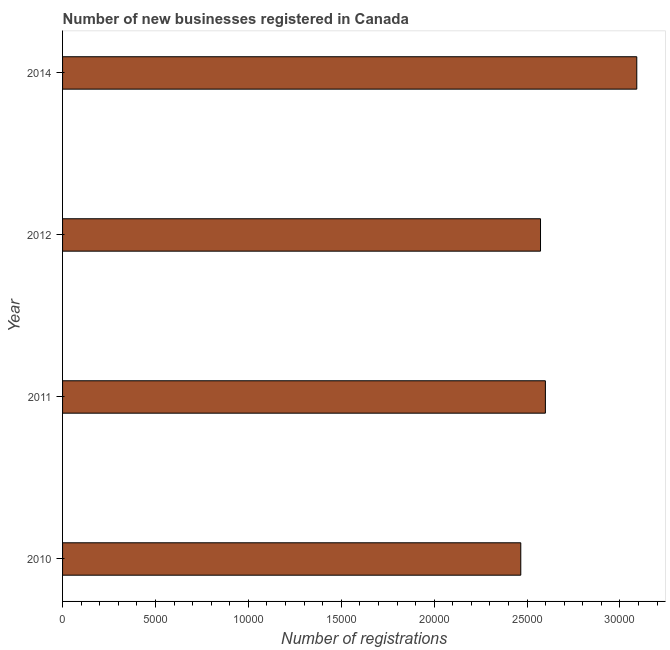Does the graph contain grids?
Keep it short and to the point. No. What is the title of the graph?
Provide a short and direct response. Number of new businesses registered in Canada. What is the label or title of the X-axis?
Give a very brief answer. Number of registrations. What is the label or title of the Y-axis?
Provide a short and direct response. Year. What is the number of new business registrations in 2014?
Ensure brevity in your answer.  3.09e+04. Across all years, what is the maximum number of new business registrations?
Keep it short and to the point. 3.09e+04. Across all years, what is the minimum number of new business registrations?
Your answer should be compact. 2.47e+04. In which year was the number of new business registrations minimum?
Offer a terse response. 2010. What is the sum of the number of new business registrations?
Provide a succinct answer. 1.07e+05. What is the difference between the number of new business registrations in 2010 and 2011?
Give a very brief answer. -1324. What is the average number of new business registrations per year?
Your response must be concise. 2.68e+04. What is the median number of new business registrations?
Provide a succinct answer. 2.59e+04. In how many years, is the number of new business registrations greater than 4000 ?
Your answer should be compact. 4. What is the ratio of the number of new business registrations in 2011 to that in 2014?
Make the answer very short. 0.84. Is the number of new business registrations in 2010 less than that in 2014?
Your answer should be compact. Yes. Is the difference between the number of new business registrations in 2010 and 2012 greater than the difference between any two years?
Your answer should be compact. No. What is the difference between the highest and the second highest number of new business registrations?
Give a very brief answer. 4919. What is the difference between the highest and the lowest number of new business registrations?
Your answer should be compact. 6243. How many bars are there?
Your response must be concise. 4. How many years are there in the graph?
Offer a very short reply. 4. What is the Number of registrations of 2010?
Make the answer very short. 2.47e+04. What is the Number of registrations in 2011?
Provide a succinct answer. 2.60e+04. What is the Number of registrations in 2012?
Make the answer very short. 2.57e+04. What is the Number of registrations in 2014?
Your answer should be very brief. 3.09e+04. What is the difference between the Number of registrations in 2010 and 2011?
Offer a very short reply. -1324. What is the difference between the Number of registrations in 2010 and 2012?
Ensure brevity in your answer.  -1062. What is the difference between the Number of registrations in 2010 and 2014?
Offer a terse response. -6243. What is the difference between the Number of registrations in 2011 and 2012?
Your answer should be very brief. 262. What is the difference between the Number of registrations in 2011 and 2014?
Offer a very short reply. -4919. What is the difference between the Number of registrations in 2012 and 2014?
Provide a short and direct response. -5181. What is the ratio of the Number of registrations in 2010 to that in 2011?
Ensure brevity in your answer.  0.95. What is the ratio of the Number of registrations in 2010 to that in 2012?
Keep it short and to the point. 0.96. What is the ratio of the Number of registrations in 2010 to that in 2014?
Ensure brevity in your answer.  0.8. What is the ratio of the Number of registrations in 2011 to that in 2012?
Give a very brief answer. 1.01. What is the ratio of the Number of registrations in 2011 to that in 2014?
Keep it short and to the point. 0.84. What is the ratio of the Number of registrations in 2012 to that in 2014?
Offer a terse response. 0.83. 